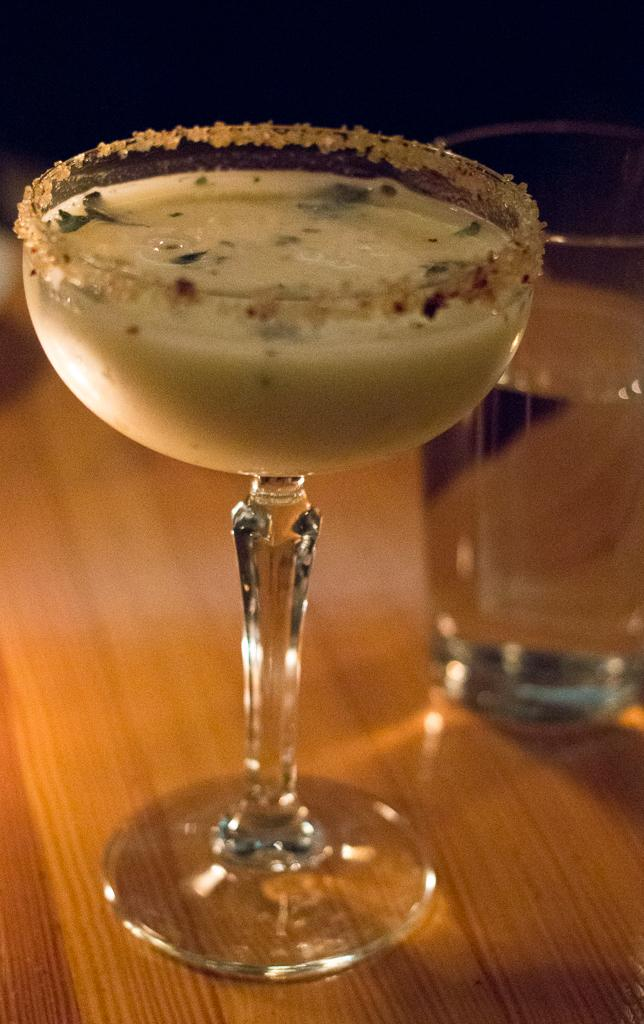What type of glass is on the table in the image? There is a wine glass on the table in the image. What is inside the wine glass? There is a sweet in the wine glass. What other type of glass is on the table? There is a glass of water on the table. What material is the table made of? The table is made of wood. What disease is being discussed by the committee in the image? There is no committee or discussion of a disease present in the image. How many cows can be seen grazing in the background of the image? There are no cows present in the image. 